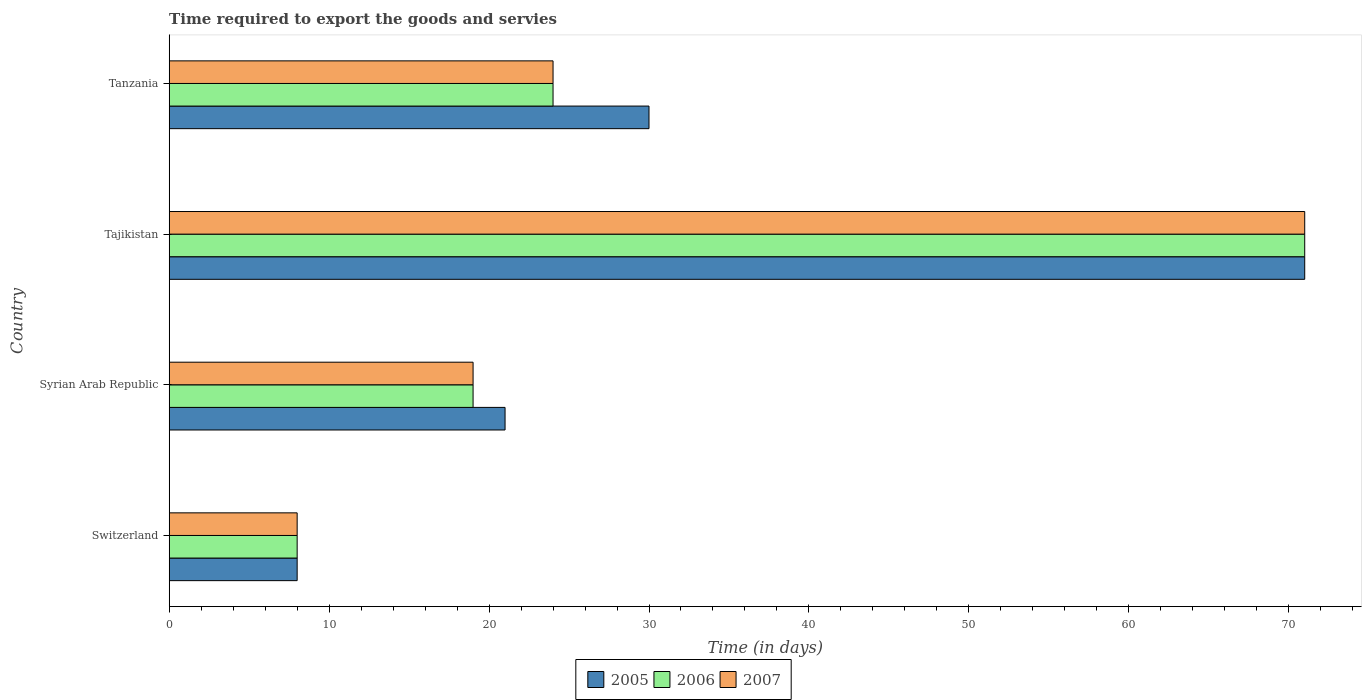Are the number of bars per tick equal to the number of legend labels?
Your answer should be very brief. Yes. Are the number of bars on each tick of the Y-axis equal?
Keep it short and to the point. Yes. How many bars are there on the 4th tick from the bottom?
Offer a terse response. 3. What is the label of the 4th group of bars from the top?
Keep it short and to the point. Switzerland. Across all countries, what is the maximum number of days required to export the goods and services in 2005?
Offer a terse response. 71. In which country was the number of days required to export the goods and services in 2007 maximum?
Your response must be concise. Tajikistan. In which country was the number of days required to export the goods and services in 2007 minimum?
Keep it short and to the point. Switzerland. What is the total number of days required to export the goods and services in 2006 in the graph?
Your answer should be compact. 122. What is the average number of days required to export the goods and services in 2006 per country?
Make the answer very short. 30.5. What is the ratio of the number of days required to export the goods and services in 2007 in Switzerland to that in Tajikistan?
Provide a succinct answer. 0.11. Is the number of days required to export the goods and services in 2005 in Syrian Arab Republic less than that in Tanzania?
Provide a short and direct response. Yes. Is the difference between the number of days required to export the goods and services in 2006 in Syrian Arab Republic and Tajikistan greater than the difference between the number of days required to export the goods and services in 2005 in Syrian Arab Republic and Tajikistan?
Make the answer very short. No. What is the difference between the highest and the lowest number of days required to export the goods and services in 2007?
Provide a succinct answer. 63. Is the sum of the number of days required to export the goods and services in 2005 in Switzerland and Tajikistan greater than the maximum number of days required to export the goods and services in 2007 across all countries?
Your answer should be compact. Yes. What does the 3rd bar from the bottom in Syrian Arab Republic represents?
Provide a succinct answer. 2007. Is it the case that in every country, the sum of the number of days required to export the goods and services in 2005 and number of days required to export the goods and services in 2006 is greater than the number of days required to export the goods and services in 2007?
Make the answer very short. Yes. How many bars are there?
Provide a succinct answer. 12. What is the difference between two consecutive major ticks on the X-axis?
Give a very brief answer. 10. Does the graph contain any zero values?
Keep it short and to the point. No. How many legend labels are there?
Make the answer very short. 3. What is the title of the graph?
Keep it short and to the point. Time required to export the goods and servies. What is the label or title of the X-axis?
Give a very brief answer. Time (in days). What is the label or title of the Y-axis?
Offer a very short reply. Country. What is the Time (in days) in 2006 in Switzerland?
Your response must be concise. 8. What is the Time (in days) in 2006 in Tajikistan?
Give a very brief answer. 71. What is the Time (in days) in 2005 in Tanzania?
Make the answer very short. 30. What is the Time (in days) in 2006 in Tanzania?
Your answer should be compact. 24. Across all countries, what is the maximum Time (in days) of 2005?
Ensure brevity in your answer.  71. Across all countries, what is the maximum Time (in days) in 2006?
Keep it short and to the point. 71. Across all countries, what is the maximum Time (in days) in 2007?
Ensure brevity in your answer.  71. What is the total Time (in days) of 2005 in the graph?
Your response must be concise. 130. What is the total Time (in days) of 2006 in the graph?
Keep it short and to the point. 122. What is the total Time (in days) of 2007 in the graph?
Offer a terse response. 122. What is the difference between the Time (in days) in 2005 in Switzerland and that in Tajikistan?
Make the answer very short. -63. What is the difference between the Time (in days) of 2006 in Switzerland and that in Tajikistan?
Offer a very short reply. -63. What is the difference between the Time (in days) of 2007 in Switzerland and that in Tajikistan?
Offer a very short reply. -63. What is the difference between the Time (in days) in 2006 in Syrian Arab Republic and that in Tajikistan?
Your answer should be compact. -52. What is the difference between the Time (in days) of 2007 in Syrian Arab Republic and that in Tajikistan?
Your answer should be very brief. -52. What is the difference between the Time (in days) in 2005 in Syrian Arab Republic and that in Tanzania?
Your answer should be compact. -9. What is the difference between the Time (in days) in 2006 in Syrian Arab Republic and that in Tanzania?
Keep it short and to the point. -5. What is the difference between the Time (in days) in 2007 in Syrian Arab Republic and that in Tanzania?
Make the answer very short. -5. What is the difference between the Time (in days) of 2006 in Tajikistan and that in Tanzania?
Offer a terse response. 47. What is the difference between the Time (in days) of 2005 in Switzerland and the Time (in days) of 2006 in Syrian Arab Republic?
Make the answer very short. -11. What is the difference between the Time (in days) in 2006 in Switzerland and the Time (in days) in 2007 in Syrian Arab Republic?
Your answer should be very brief. -11. What is the difference between the Time (in days) in 2005 in Switzerland and the Time (in days) in 2006 in Tajikistan?
Your answer should be very brief. -63. What is the difference between the Time (in days) in 2005 in Switzerland and the Time (in days) in 2007 in Tajikistan?
Give a very brief answer. -63. What is the difference between the Time (in days) of 2006 in Switzerland and the Time (in days) of 2007 in Tajikistan?
Ensure brevity in your answer.  -63. What is the difference between the Time (in days) of 2005 in Switzerland and the Time (in days) of 2006 in Tanzania?
Offer a very short reply. -16. What is the difference between the Time (in days) in 2005 in Syrian Arab Republic and the Time (in days) in 2006 in Tajikistan?
Ensure brevity in your answer.  -50. What is the difference between the Time (in days) of 2005 in Syrian Arab Republic and the Time (in days) of 2007 in Tajikistan?
Make the answer very short. -50. What is the difference between the Time (in days) in 2006 in Syrian Arab Republic and the Time (in days) in 2007 in Tajikistan?
Provide a short and direct response. -52. What is the difference between the Time (in days) of 2005 in Syrian Arab Republic and the Time (in days) of 2006 in Tanzania?
Provide a short and direct response. -3. What is the difference between the Time (in days) of 2005 in Tajikistan and the Time (in days) of 2006 in Tanzania?
Your response must be concise. 47. What is the difference between the Time (in days) in 2005 in Tajikistan and the Time (in days) in 2007 in Tanzania?
Keep it short and to the point. 47. What is the difference between the Time (in days) of 2006 in Tajikistan and the Time (in days) of 2007 in Tanzania?
Keep it short and to the point. 47. What is the average Time (in days) of 2005 per country?
Your response must be concise. 32.5. What is the average Time (in days) of 2006 per country?
Your answer should be very brief. 30.5. What is the average Time (in days) of 2007 per country?
Offer a terse response. 30.5. What is the difference between the Time (in days) in 2005 and Time (in days) in 2006 in Switzerland?
Provide a succinct answer. 0. What is the difference between the Time (in days) in 2006 and Time (in days) in 2007 in Syrian Arab Republic?
Offer a terse response. 0. What is the difference between the Time (in days) in 2006 and Time (in days) in 2007 in Tanzania?
Your response must be concise. 0. What is the ratio of the Time (in days) in 2005 in Switzerland to that in Syrian Arab Republic?
Your response must be concise. 0.38. What is the ratio of the Time (in days) of 2006 in Switzerland to that in Syrian Arab Republic?
Give a very brief answer. 0.42. What is the ratio of the Time (in days) in 2007 in Switzerland to that in Syrian Arab Republic?
Ensure brevity in your answer.  0.42. What is the ratio of the Time (in days) in 2005 in Switzerland to that in Tajikistan?
Give a very brief answer. 0.11. What is the ratio of the Time (in days) of 2006 in Switzerland to that in Tajikistan?
Keep it short and to the point. 0.11. What is the ratio of the Time (in days) in 2007 in Switzerland to that in Tajikistan?
Your response must be concise. 0.11. What is the ratio of the Time (in days) of 2005 in Switzerland to that in Tanzania?
Provide a succinct answer. 0.27. What is the ratio of the Time (in days) in 2005 in Syrian Arab Republic to that in Tajikistan?
Offer a terse response. 0.3. What is the ratio of the Time (in days) in 2006 in Syrian Arab Republic to that in Tajikistan?
Ensure brevity in your answer.  0.27. What is the ratio of the Time (in days) of 2007 in Syrian Arab Republic to that in Tajikistan?
Provide a short and direct response. 0.27. What is the ratio of the Time (in days) of 2006 in Syrian Arab Republic to that in Tanzania?
Ensure brevity in your answer.  0.79. What is the ratio of the Time (in days) in 2007 in Syrian Arab Republic to that in Tanzania?
Give a very brief answer. 0.79. What is the ratio of the Time (in days) of 2005 in Tajikistan to that in Tanzania?
Provide a succinct answer. 2.37. What is the ratio of the Time (in days) of 2006 in Tajikistan to that in Tanzania?
Make the answer very short. 2.96. What is the ratio of the Time (in days) in 2007 in Tajikistan to that in Tanzania?
Make the answer very short. 2.96. What is the difference between the highest and the second highest Time (in days) of 2005?
Make the answer very short. 41. What is the difference between the highest and the second highest Time (in days) of 2006?
Your answer should be very brief. 47. What is the difference between the highest and the lowest Time (in days) of 2005?
Keep it short and to the point. 63. What is the difference between the highest and the lowest Time (in days) of 2006?
Ensure brevity in your answer.  63. What is the difference between the highest and the lowest Time (in days) of 2007?
Your answer should be compact. 63. 